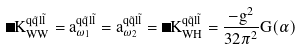Convert formula to latex. <formula><loc_0><loc_0><loc_500><loc_500>\Delta K _ { W W } ^ { q \tilde { q } l \tilde { l } } = a _ { \omega _ { 1 } } ^ { q \tilde { q } l \tilde { l } } = a _ { \omega _ { 2 } } ^ { q \tilde { q } l \tilde { l } } = \Delta K _ { W H } ^ { q \tilde { q } l \tilde { l } } = \frac { - g ^ { 2 } } { 3 2 \pi ^ { 2 } } G ( \alpha )</formula> 